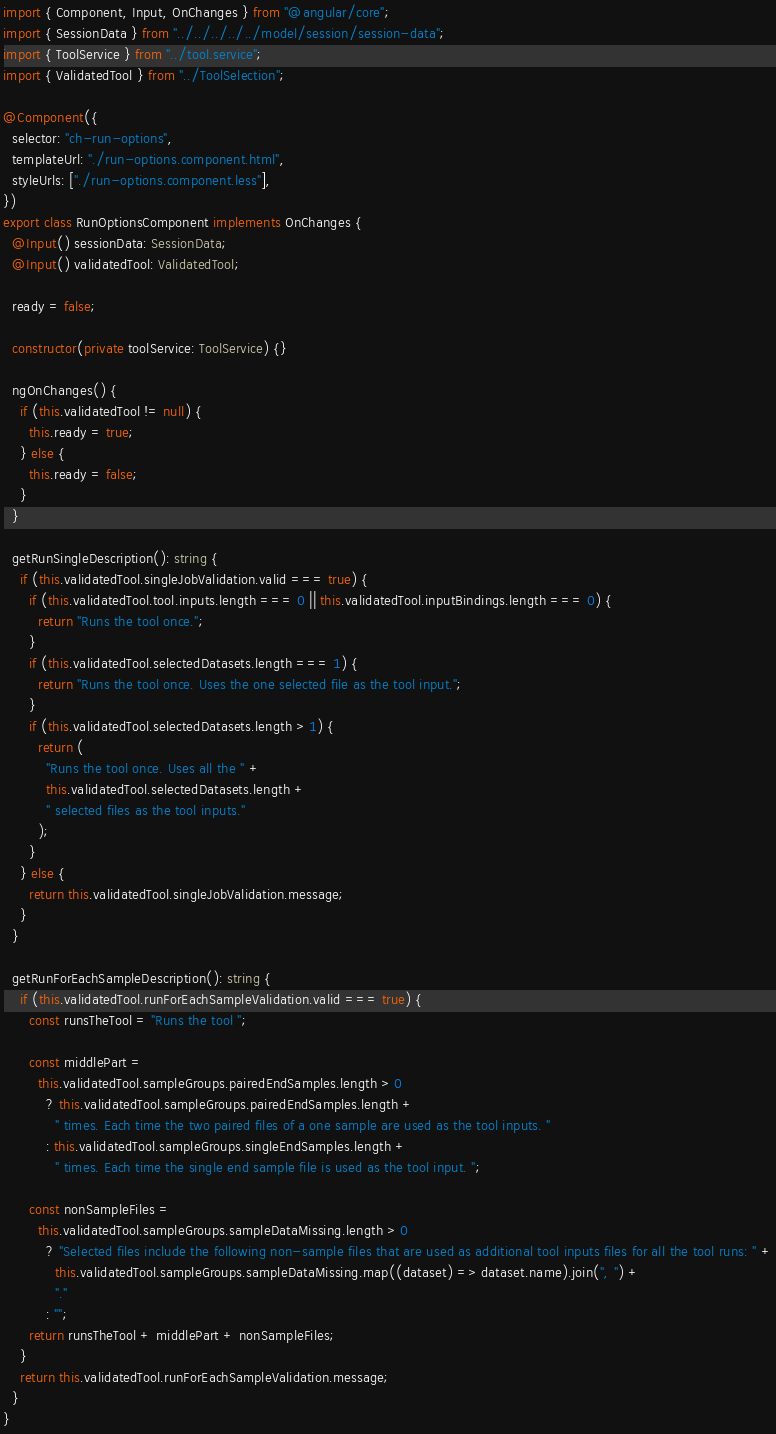<code> <loc_0><loc_0><loc_500><loc_500><_TypeScript_>import { Component, Input, OnChanges } from "@angular/core";
import { SessionData } from "../../../../../model/session/session-data";
import { ToolService } from "../tool.service";
import { ValidatedTool } from "../ToolSelection";

@Component({
  selector: "ch-run-options",
  templateUrl: "./run-options.component.html",
  styleUrls: ["./run-options.component.less"],
})
export class RunOptionsComponent implements OnChanges {
  @Input() sessionData: SessionData;
  @Input() validatedTool: ValidatedTool;

  ready = false;

  constructor(private toolService: ToolService) {}

  ngOnChanges() {
    if (this.validatedTool != null) {
      this.ready = true;
    } else {
      this.ready = false;
    }
  }

  getRunSingleDescription(): string {
    if (this.validatedTool.singleJobValidation.valid === true) {
      if (this.validatedTool.tool.inputs.length === 0 || this.validatedTool.inputBindings.length === 0) {
        return "Runs the tool once.";
      }
      if (this.validatedTool.selectedDatasets.length === 1) {
        return "Runs the tool once. Uses the one selected file as the tool input.";
      }
      if (this.validatedTool.selectedDatasets.length > 1) {
        return (
          "Runs the tool once. Uses all the " +
          this.validatedTool.selectedDatasets.length +
          " selected files as the tool inputs."
        );
      }
    } else {
      return this.validatedTool.singleJobValidation.message;
    }
  }

  getRunForEachSampleDescription(): string {
    if (this.validatedTool.runForEachSampleValidation.valid === true) {
      const runsTheTool = "Runs the tool ";

      const middlePart =
        this.validatedTool.sampleGroups.pairedEndSamples.length > 0
          ? this.validatedTool.sampleGroups.pairedEndSamples.length +
            " times. Each time the two paired files of a one sample are used as the tool inputs. "
          : this.validatedTool.sampleGroups.singleEndSamples.length +
            " times. Each time the single end sample file is used as the tool input. ";

      const nonSampleFiles =
        this.validatedTool.sampleGroups.sampleDataMissing.length > 0
          ? "Selected files include the following non-sample files that are used as additional tool inputs files for all the tool runs: " +
            this.validatedTool.sampleGroups.sampleDataMissing.map((dataset) => dataset.name).join(", ") +
            "."
          : "";
      return runsTheTool + middlePart + nonSampleFiles;
    }
    return this.validatedTool.runForEachSampleValidation.message;
  }
}
</code> 